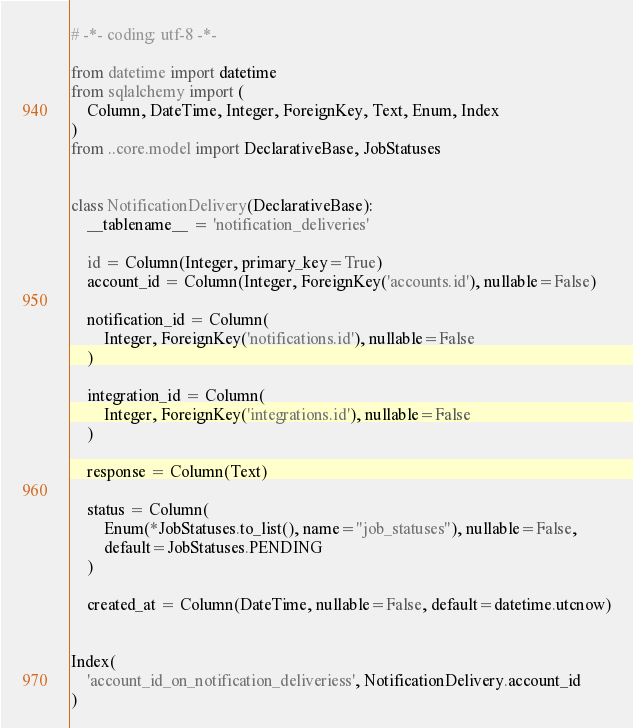<code> <loc_0><loc_0><loc_500><loc_500><_Python_># -*- coding: utf-8 -*-

from datetime import datetime
from sqlalchemy import (
    Column, DateTime, Integer, ForeignKey, Text, Enum, Index
)
from ..core.model import DeclarativeBase, JobStatuses


class NotificationDelivery(DeclarativeBase):
    __tablename__ = 'notification_deliveries'

    id = Column(Integer, primary_key=True)
    account_id = Column(Integer, ForeignKey('accounts.id'), nullable=False)

    notification_id = Column(
        Integer, ForeignKey('notifications.id'), nullable=False
    )

    integration_id = Column(
        Integer, ForeignKey('integrations.id'), nullable=False
    )

    response = Column(Text)

    status = Column(
        Enum(*JobStatuses.to_list(), name="job_statuses"), nullable=False,
        default=JobStatuses.PENDING
    )

    created_at = Column(DateTime, nullable=False, default=datetime.utcnow)


Index(
    'account_id_on_notification_deliveriess', NotificationDelivery.account_id
)
</code> 